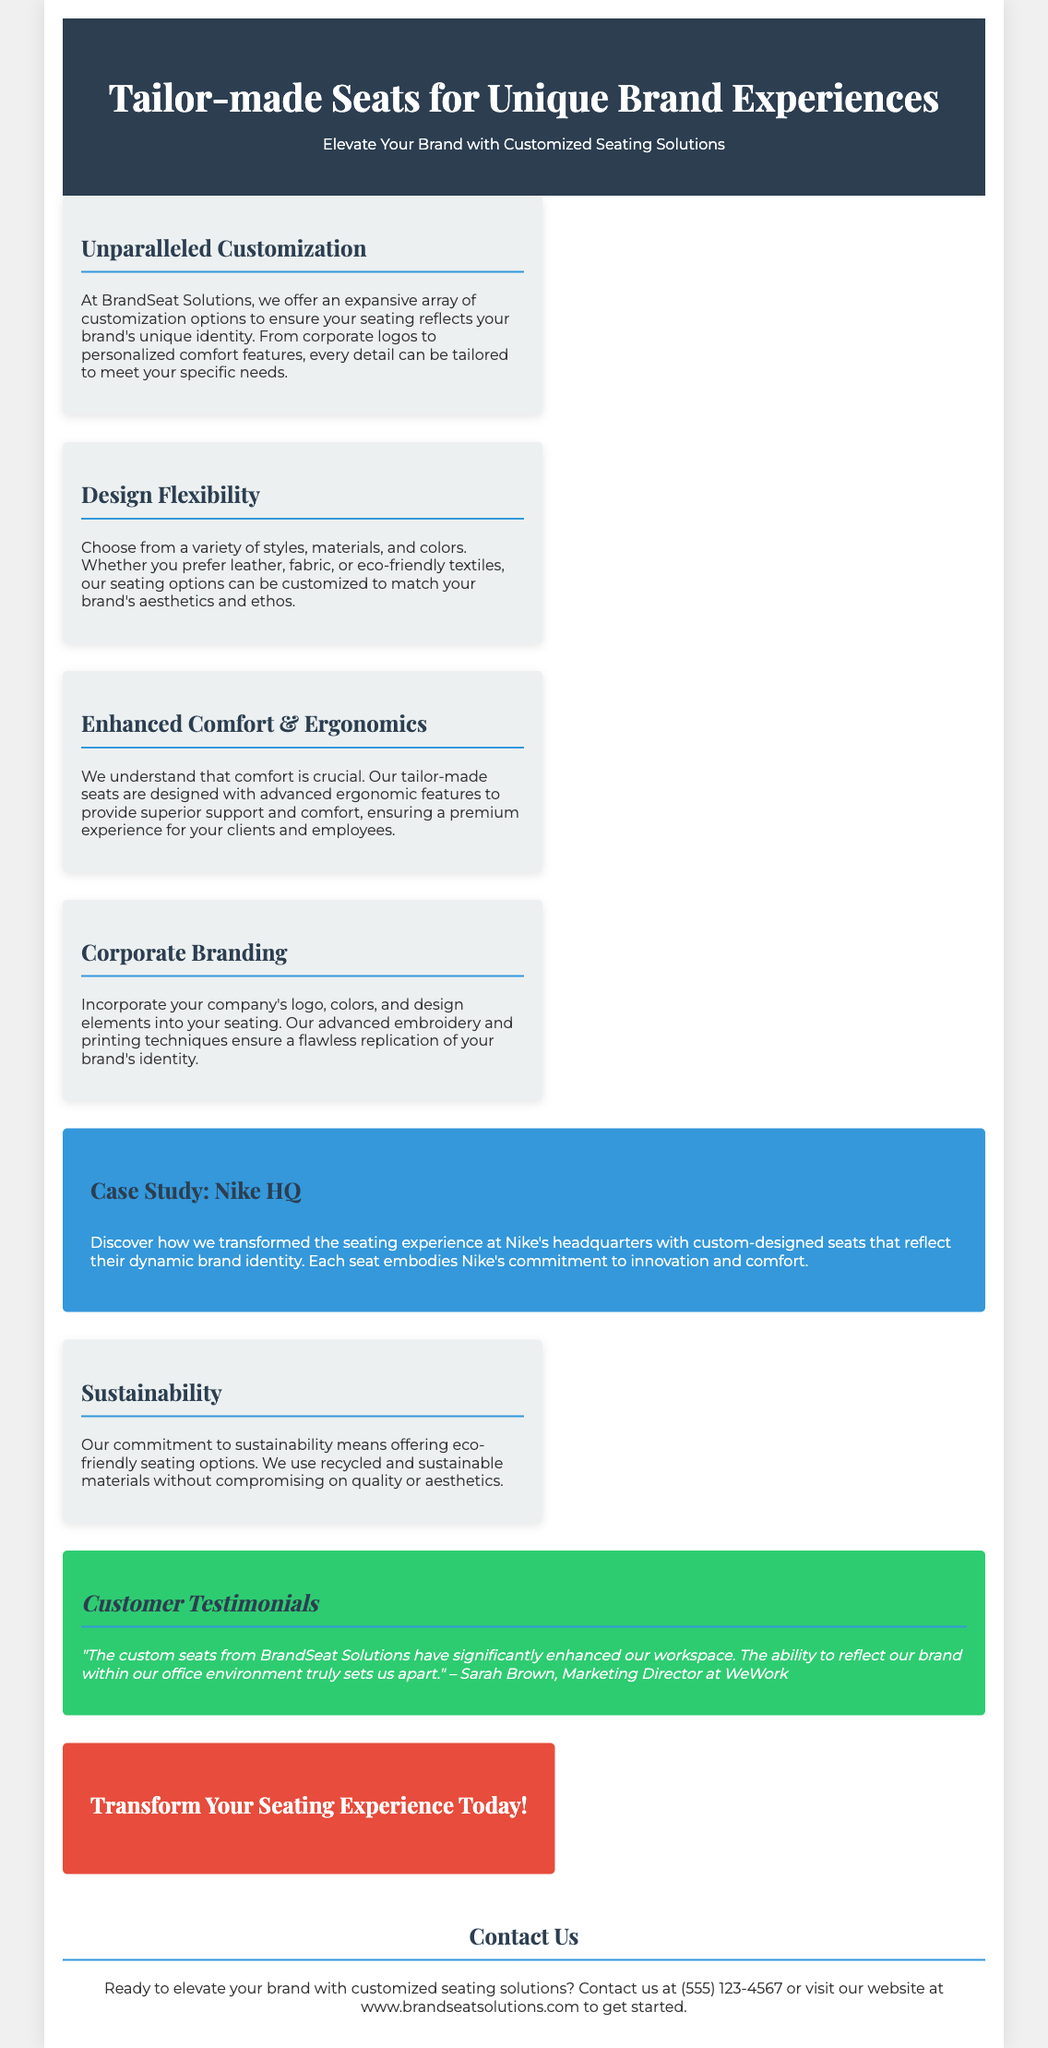What is the name of the company offering customization options? The name of the company is mentioned in the document as "BrandSeat Solutions."
Answer: BrandSeat Solutions What is one type of material that can be chosen for the seats? The document lists "leather, fabric, or eco-friendly textiles" as options for materials.
Answer: leather What feature is emphasized for the tailor-made seats? The document highlights "advanced ergonomic features" as a primary focus for comfort.
Answer: ergonomic What is the contact phone number provided in the flyer? The contact phone number given in the document is "(555) 123-4567."
Answer: (555) 123-4567 Which company's headquarters is used as a case study? The case study mentioned in the document is for "Nike."
Answer: Nike What color is used for the company’s branding in the document? The document uses "white" and "blue" prominently, with many sections using a blue color for branding purposes.
Answer: blue In what year was customer Sarah Brown interviewed? The document does not provide a specific year for the interview.
Answer: not specified What is the transformative impact of the seats according to the testimonial? Sarah Brown states that the custom seats enhance the workspace and reflect the brand in the office environment.
Answer: enhance our workspace What type of seating options does the company commit to providing? The document states a commitment to "eco-friendly seating options."
Answer: eco-friendly seating options 